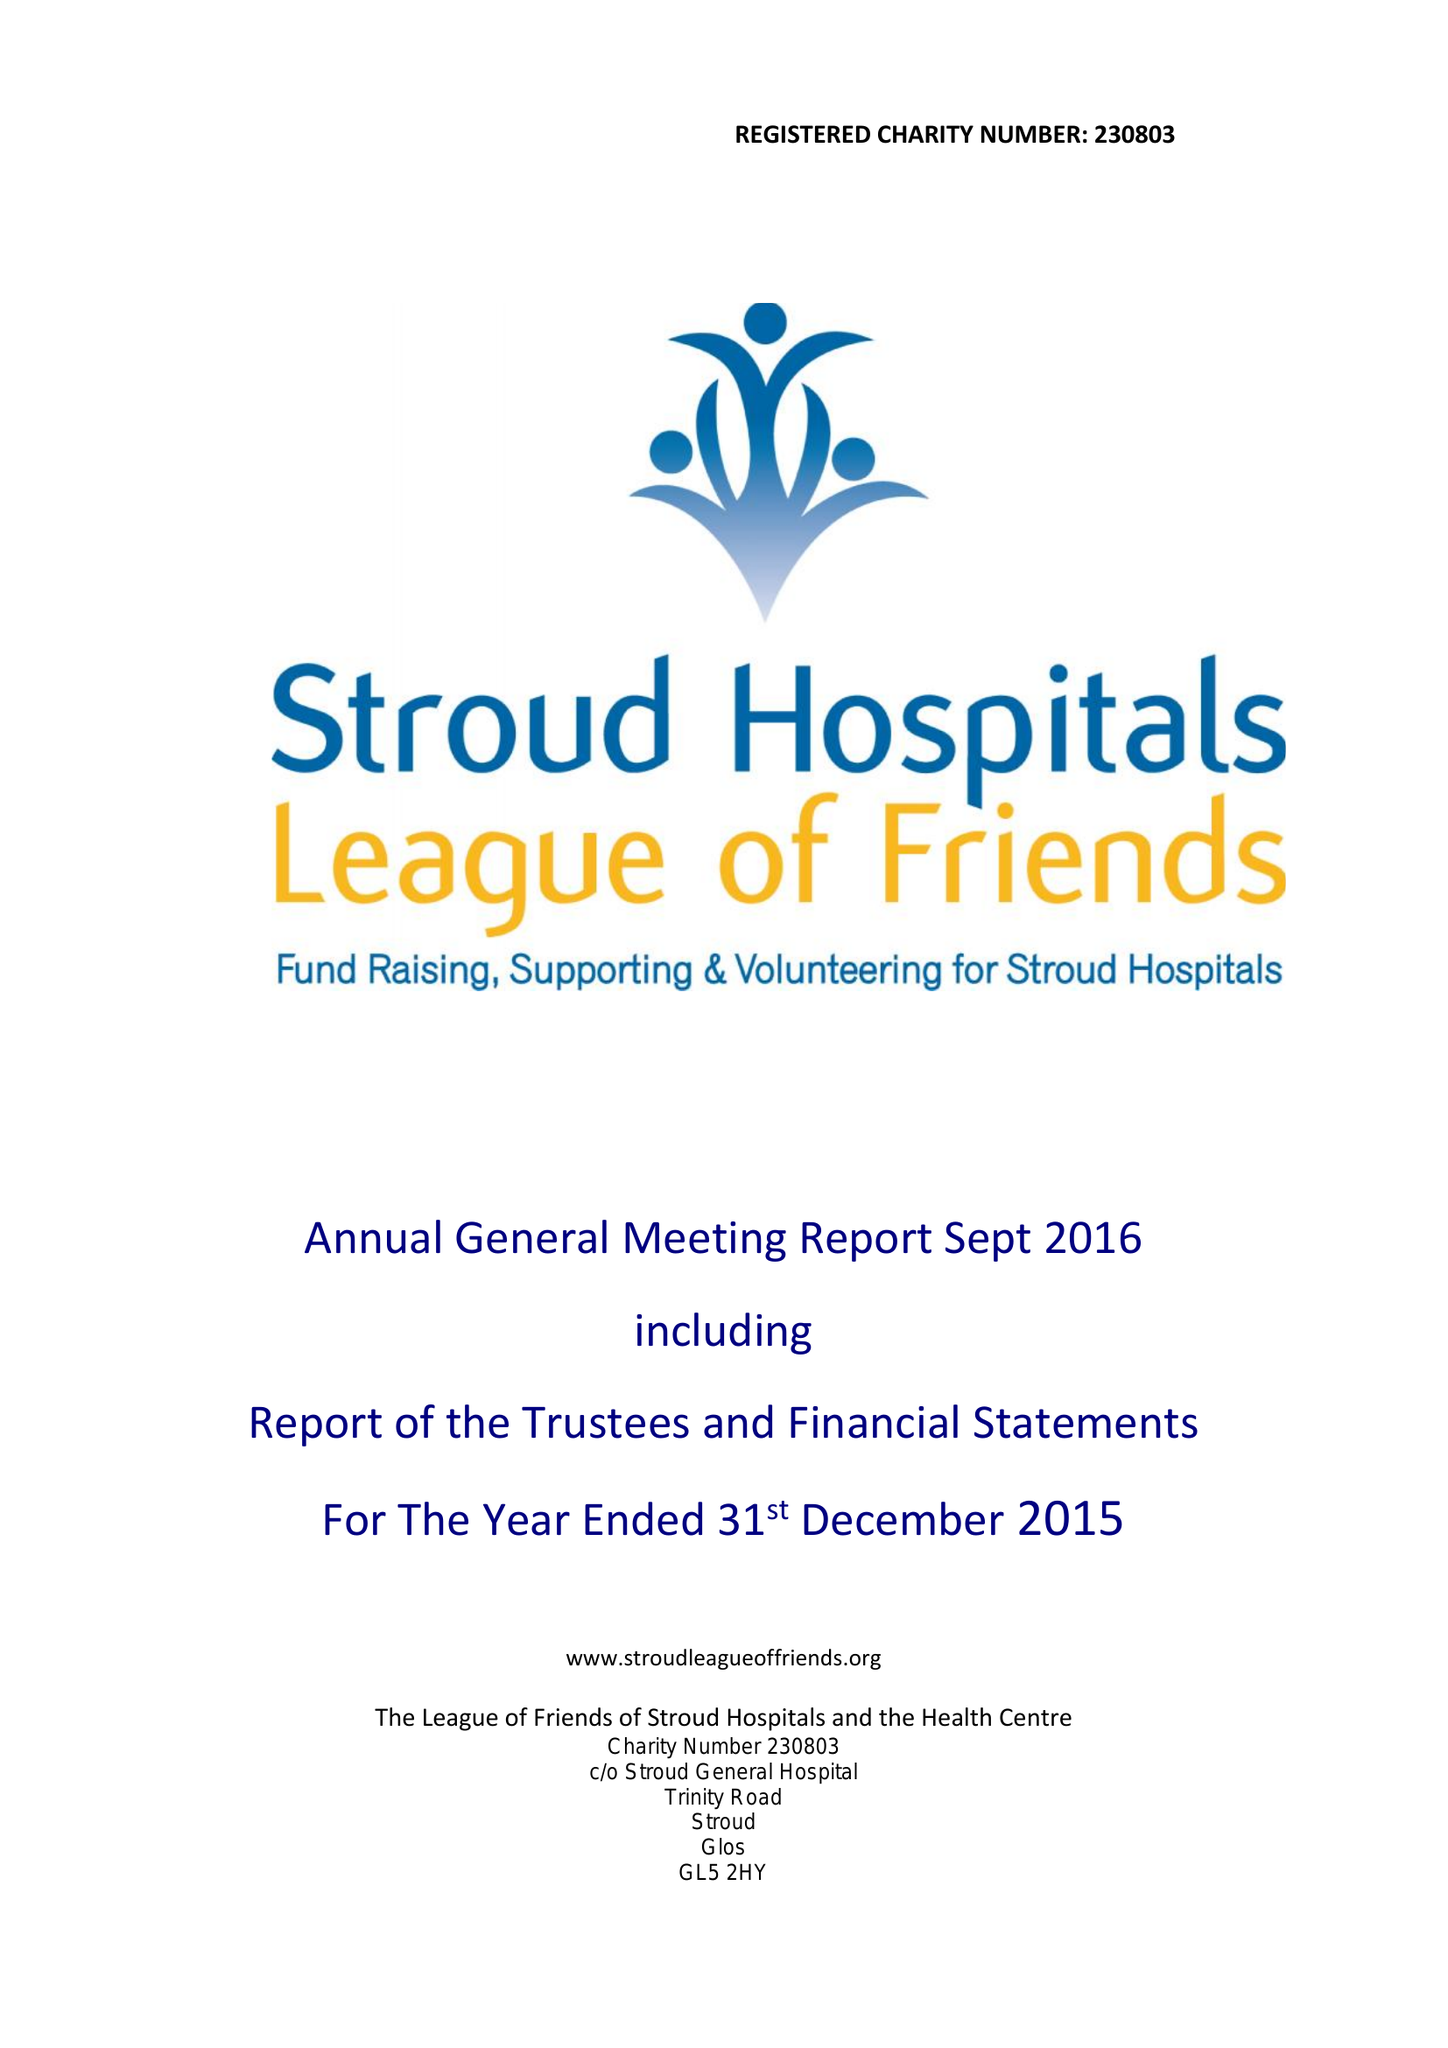What is the value for the spending_annually_in_british_pounds?
Answer the question using a single word or phrase. 170862.00 